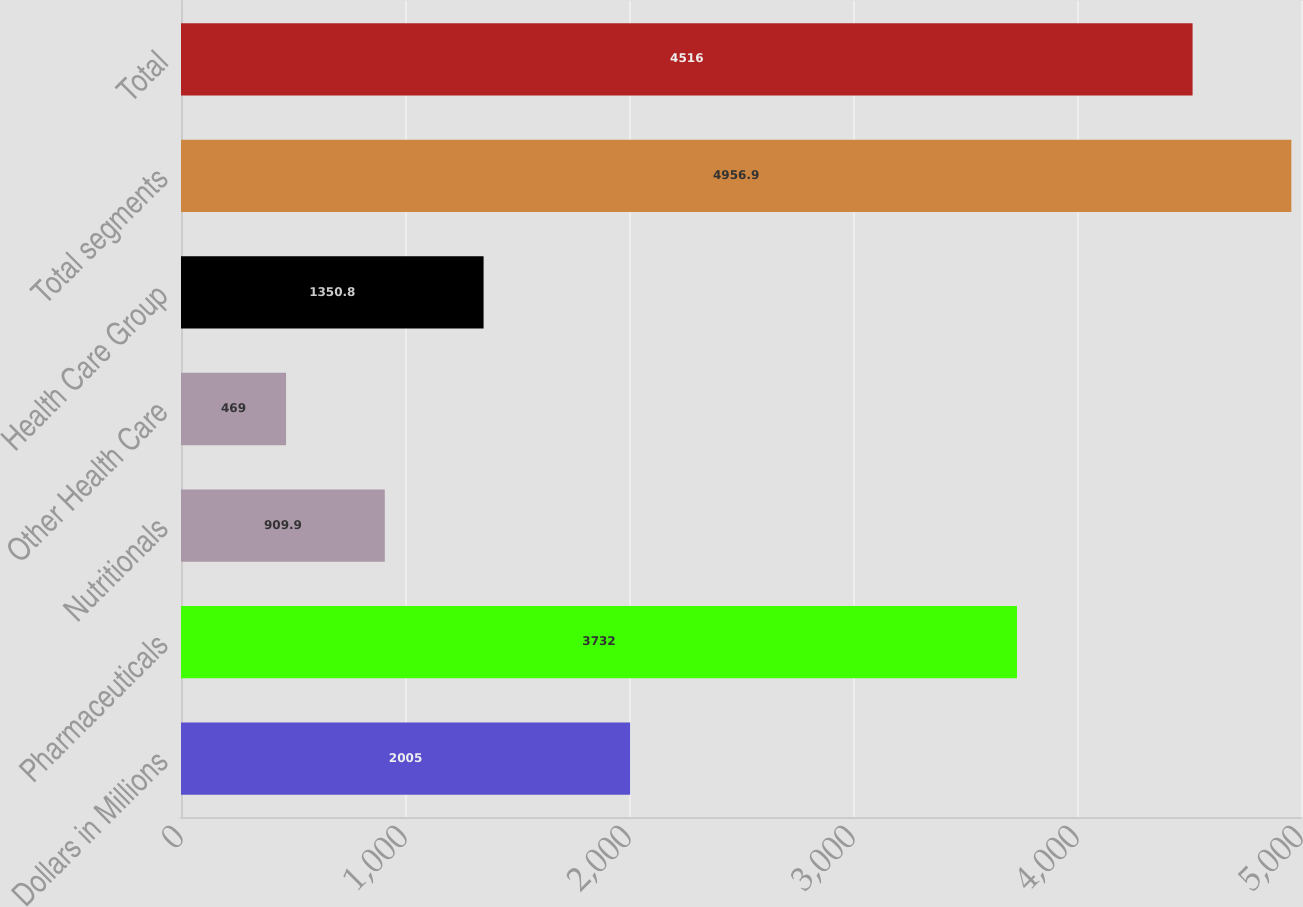Convert chart. <chart><loc_0><loc_0><loc_500><loc_500><bar_chart><fcel>Dollars in Millions<fcel>Pharmaceuticals<fcel>Nutritionals<fcel>Other Health Care<fcel>Health Care Group<fcel>Total segments<fcel>Total<nl><fcel>2005<fcel>3732<fcel>909.9<fcel>469<fcel>1350.8<fcel>4956.9<fcel>4516<nl></chart> 